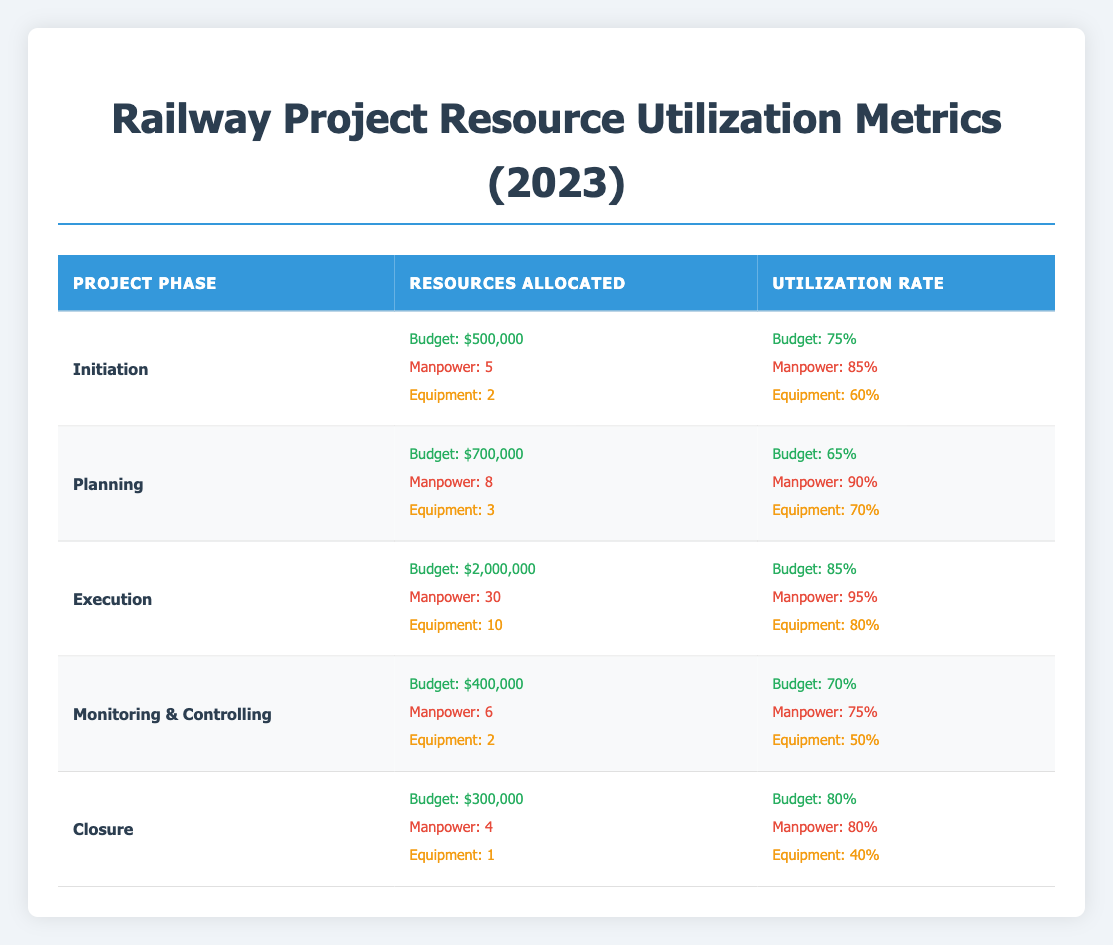What is the total budget allocated for the Execution phase? The budget allocated for the Execution phase is $2,000,000. The value can be found directly in the budget allocated for that phase in the table.
Answer: 2,000,000 Which project phase has the highest manpower utilization rate? The Execution phase has the highest manpower utilization rate at 95%. This is observed by comparing the manpower utilization rates across all project phases in the table.
Answer: Execution What is the average equipment utilization across all phases? To find the average equipment utilization, sum the equipment utilization rates for all phases: (60 + 70 + 80 + 50 + 40) = 300. Then, divide by the number of phases, which is 5. Thus, the average is 300 / 5 = 60.
Answer: 60 Is the budget utilization for the Planning phase greater than for the Initiation phase? The budget utilization for the Planning phase is 65%, while for the Initiation phase, it is 75%. As 65% is less than 75%, the statement is false.
Answer: No What is the difference in budget allocation between the Execution phase and the Closure phase? The budget for the Execution phase is $2,000,000 and for the Closure phase, it is $300,000. The difference is calculated as $2,000,000 - $300,000 = $1,700,000.
Answer: 1,700,000 Which phase has the lowest equipment utilization rate? The Closure phase has the lowest equipment utilization rate at 40%. This is determined by comparing the equipment utilization rates of all project phases listed in the table.
Answer: Closure What is the total manpower allocated across all project phases? To find the total manpower allocated, sum the manpower for each phase: 5 + 8 + 30 + 6 + 4 = 53.
Answer: 53 Is the equipment utilization for the Monitoring & Controlling phase lower than the average equipment utilization? The equipment utilization for the Monitoring & Controlling phase is 50%, while the average equipment utilization determined previously is 60%. Since 50% is less than 60%, the statement is true.
Answer: Yes What is the budget utilization rate trend as we move from the Initiation to the Execution phase? The budget utilization rates are 75% (Initiation), 65% (Planning), and 85% (Execution). This indicates a decrease from Initiation to Planning, followed by an increase to Execution. Hence, the trend is a decline followed by an increase.
Answer: Decline then increase 